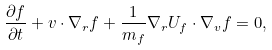Convert formula to latex. <formula><loc_0><loc_0><loc_500><loc_500>\frac { \partial f } { \partial t } + { v } \cdot \nabla _ { r } f + \frac { 1 } { m _ { f } } \nabla _ { r } U _ { f } \cdot \nabla _ { v } f = 0 ,</formula> 